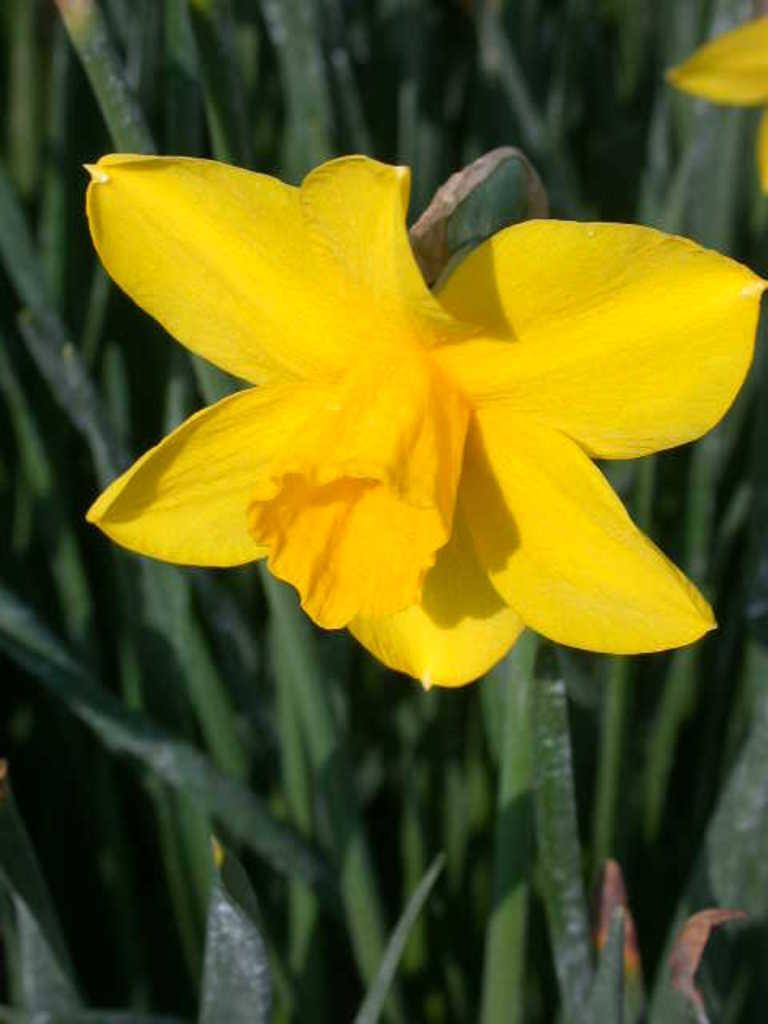Please provide a concise description of this image. This is the picture of a flower. In this image there are yellow color flowers on the green plants. 